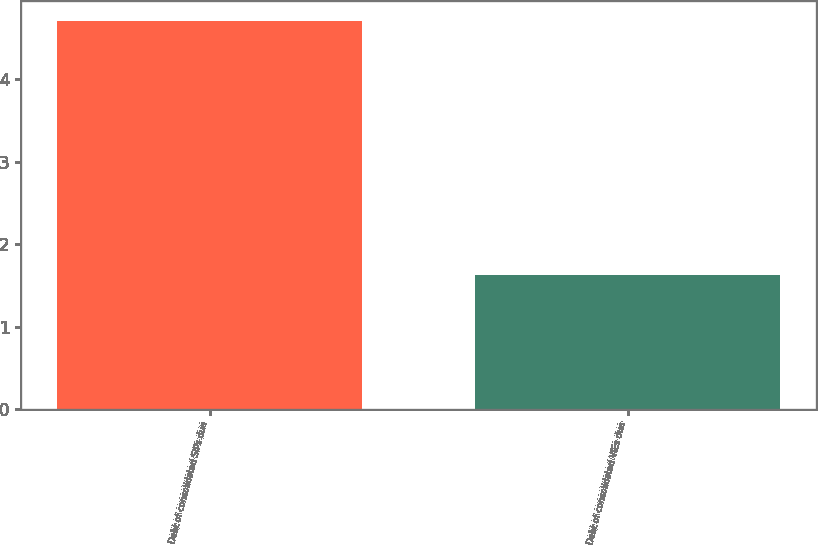Convert chart. <chart><loc_0><loc_0><loc_500><loc_500><bar_chart><fcel>Debt of consolidated SIPs due<fcel>Debt of consolidated VIEs due<nl><fcel>4.71<fcel>1.62<nl></chart> 